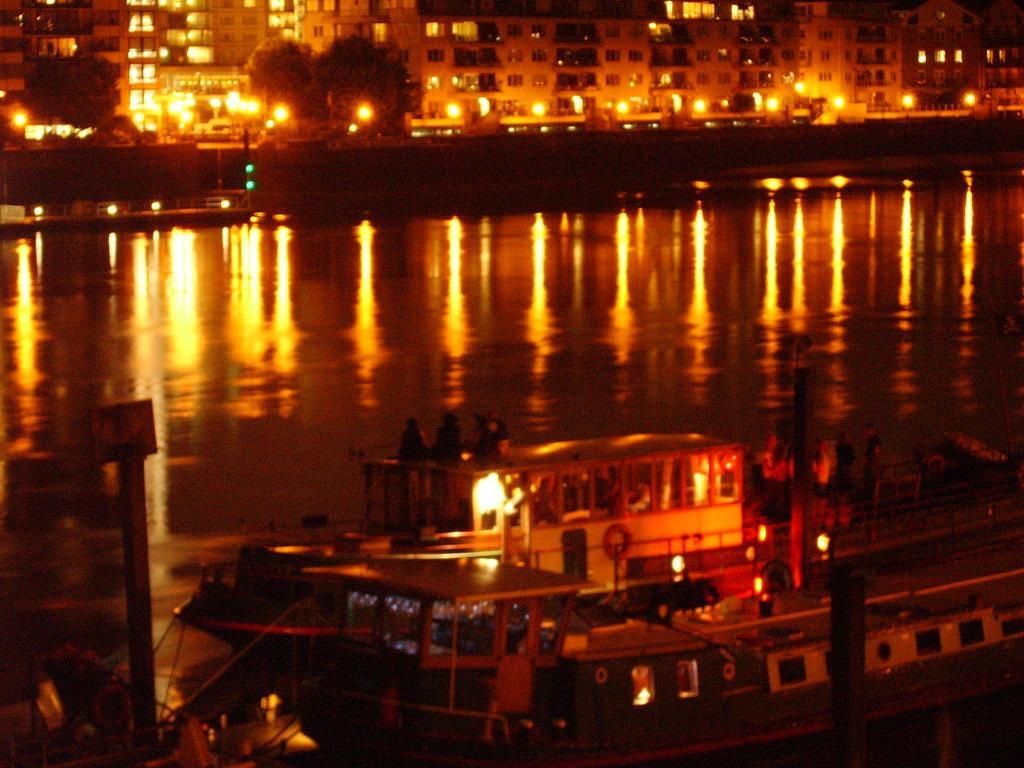Please provide a concise description of this image. This is an image clicked in the dark. At the bottom of the image I can see a ship on the water. In the background there are some buildings, trees and lights. 